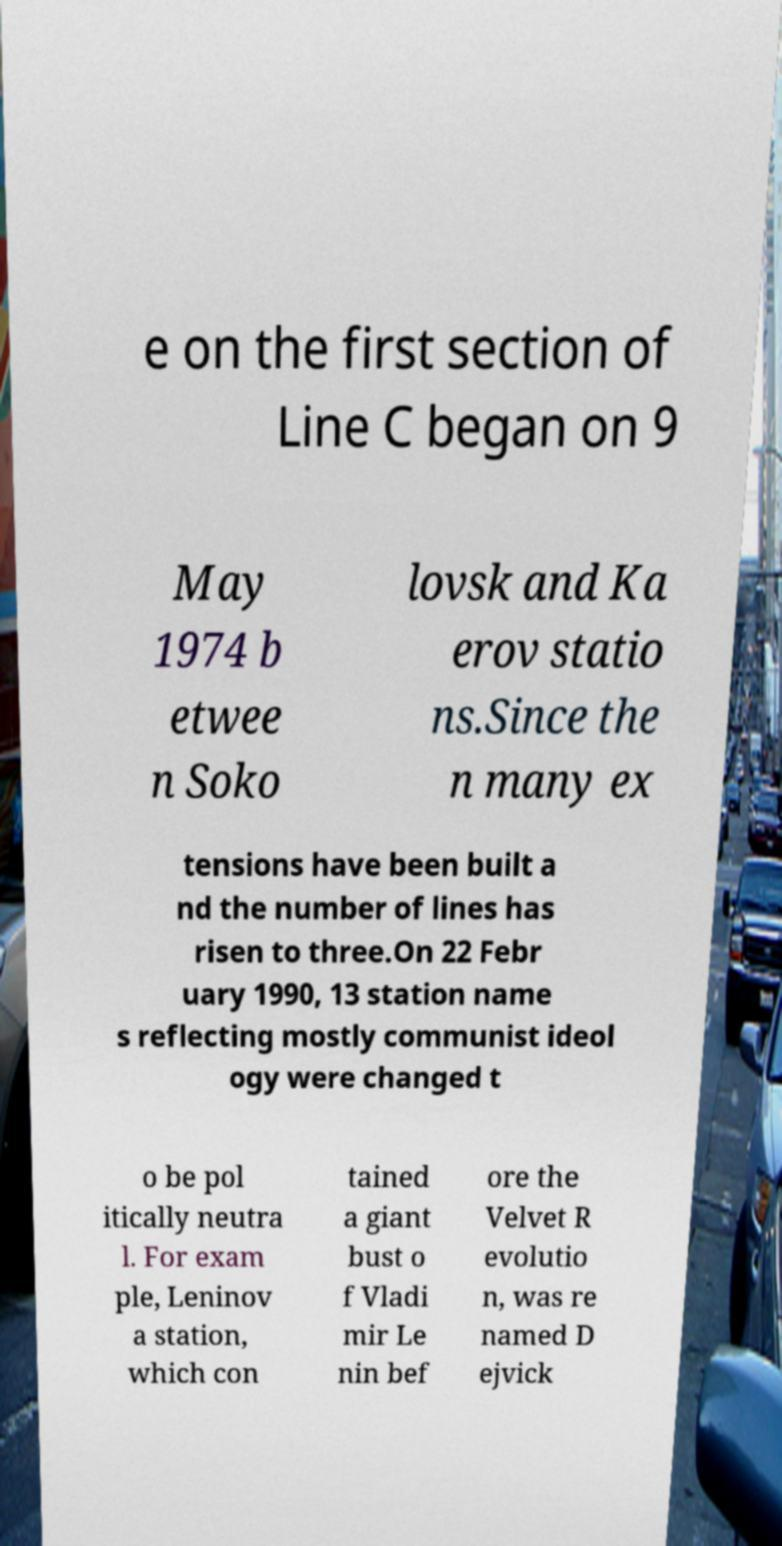I need the written content from this picture converted into text. Can you do that? e on the first section of Line C began on 9 May 1974 b etwee n Soko lovsk and Ka erov statio ns.Since the n many ex tensions have been built a nd the number of lines has risen to three.On 22 Febr uary 1990, 13 station name s reflecting mostly communist ideol ogy were changed t o be pol itically neutra l. For exam ple, Leninov a station, which con tained a giant bust o f Vladi mir Le nin bef ore the Velvet R evolutio n, was re named D ejvick 